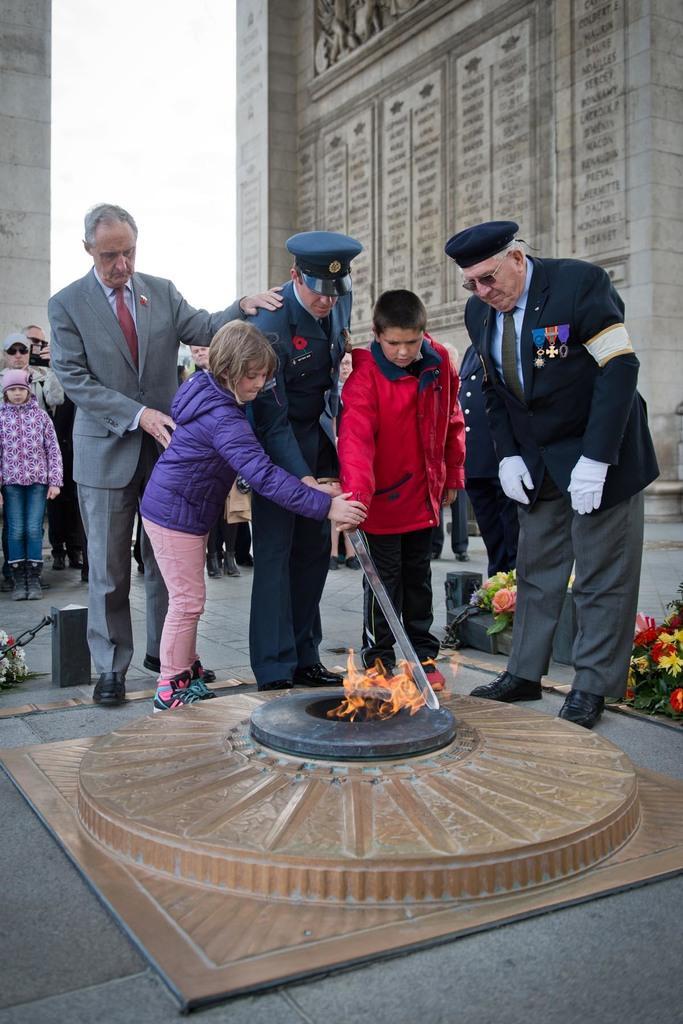Please provide a concise description of this image. In this image we can see some persons and police man standing near something in which there is flame, on right side of the image there are some flowers and in the background of the image there are some persons standing and there is a wall. 